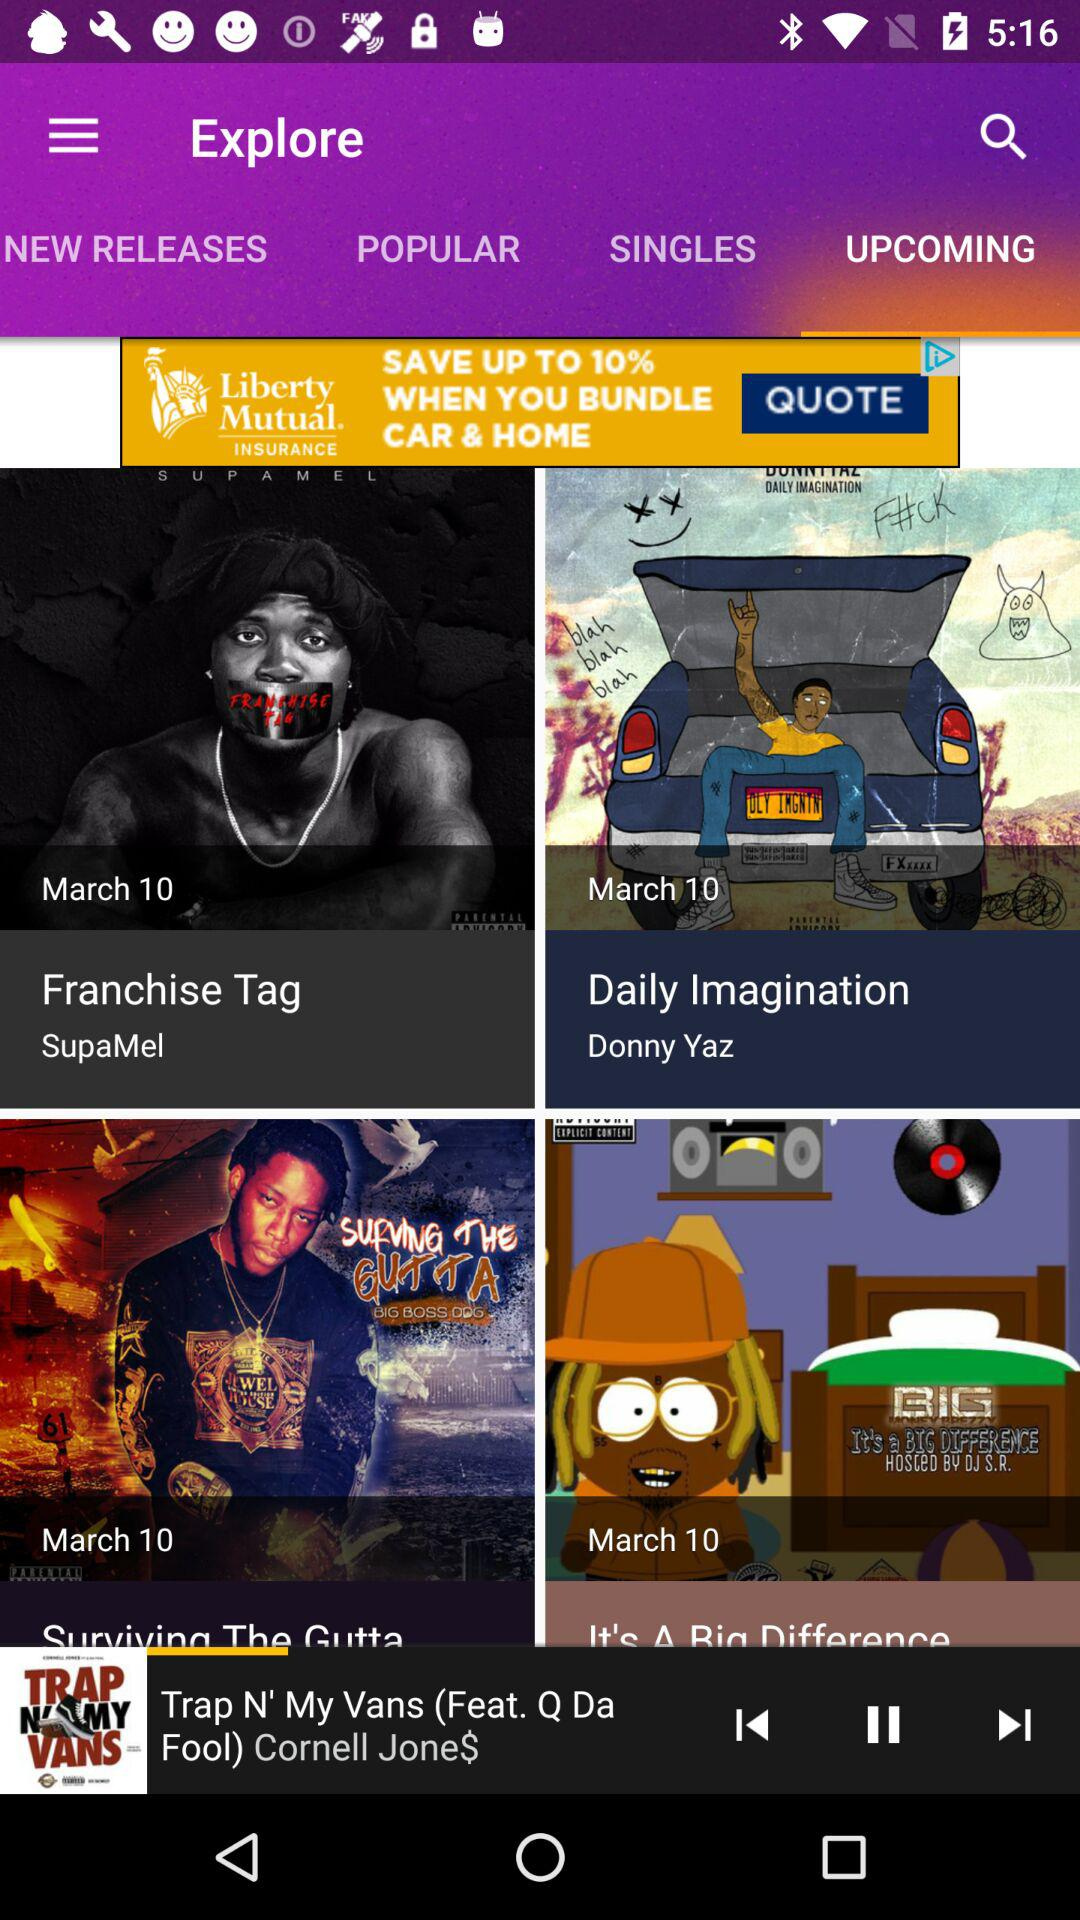Who is the artist of "Franchise Tag"? The artist is SupaMel. 